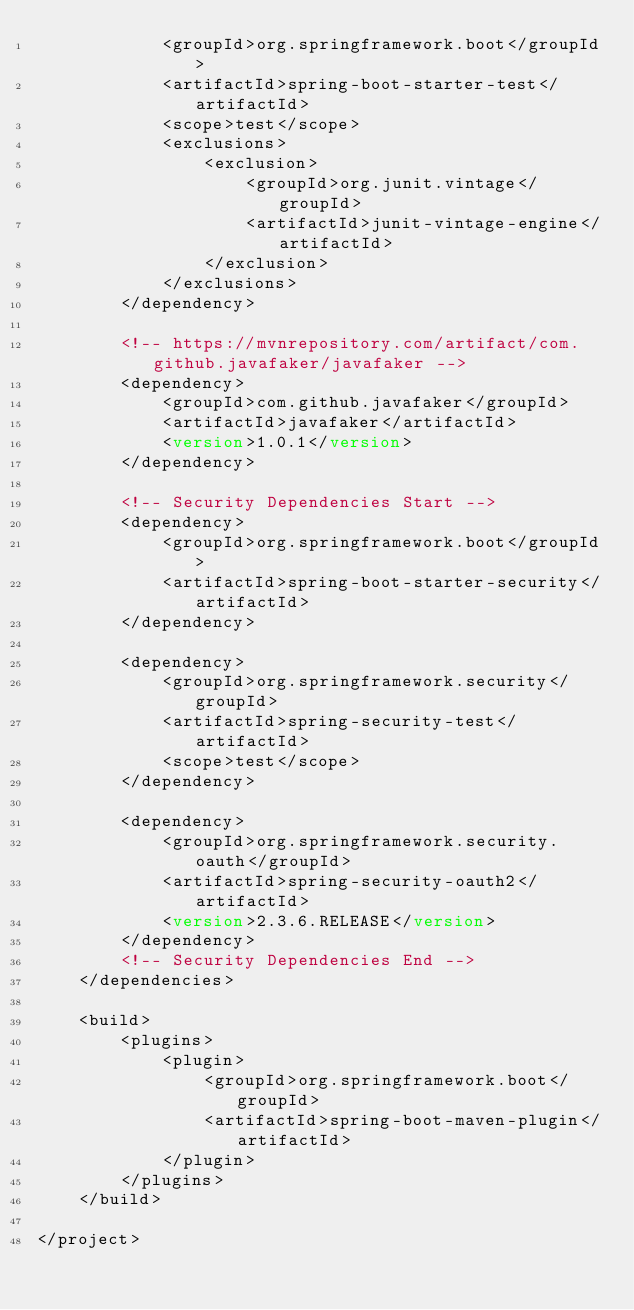<code> <loc_0><loc_0><loc_500><loc_500><_XML_>            <groupId>org.springframework.boot</groupId>
            <artifactId>spring-boot-starter-test</artifactId>
            <scope>test</scope>
            <exclusions>
                <exclusion>
                    <groupId>org.junit.vintage</groupId>
                    <artifactId>junit-vintage-engine</artifactId>
                </exclusion>
            </exclusions>
        </dependency>

        <!-- https://mvnrepository.com/artifact/com.github.javafaker/javafaker -->
        <dependency>
            <groupId>com.github.javafaker</groupId>
            <artifactId>javafaker</artifactId>
            <version>1.0.1</version>
        </dependency>

        <!-- Security Dependencies Start -->
        <dependency>
            <groupId>org.springframework.boot</groupId>
            <artifactId>spring-boot-starter-security</artifactId>
        </dependency>

        <dependency>
            <groupId>org.springframework.security</groupId>
            <artifactId>spring-security-test</artifactId>
            <scope>test</scope>
        </dependency>

        <dependency>
            <groupId>org.springframework.security.oauth</groupId>
            <artifactId>spring-security-oauth2</artifactId>
            <version>2.3.6.RELEASE</version>
        </dependency>
        <!-- Security Dependencies End -->
    </dependencies>

    <build>
        <plugins>
            <plugin>
                <groupId>org.springframework.boot</groupId>
                <artifactId>spring-boot-maven-plugin</artifactId>
            </plugin>
        </plugins>
    </build>

</project>
</code> 